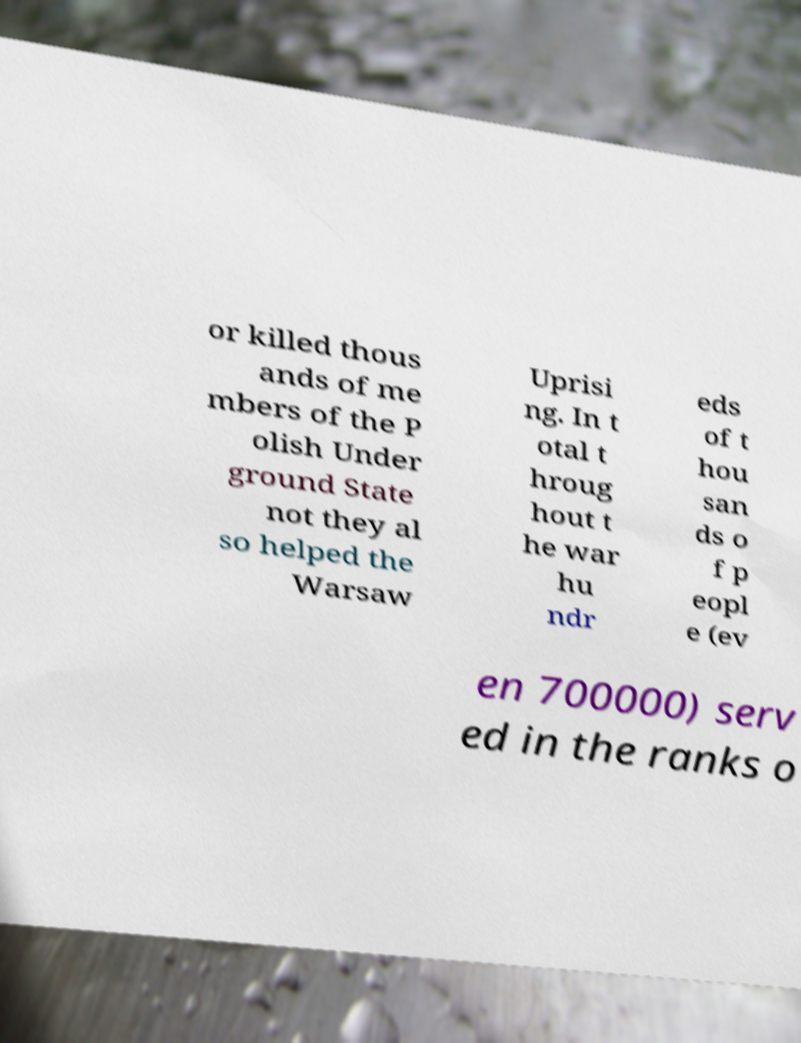Please identify and transcribe the text found in this image. or killed thous ands of me mbers of the P olish Under ground State not they al so helped the Warsaw Uprisi ng. In t otal t hroug hout t he war hu ndr eds of t hou san ds o f p eopl e (ev en 700000) serv ed in the ranks o 